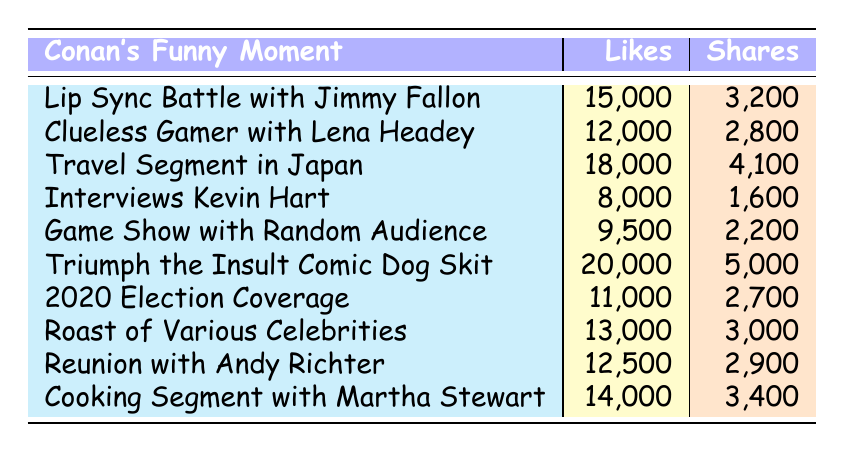What is the moment with the highest number of likes? By looking at the "Likes" column, the maximum value is 20,000, which corresponds to "Triumph the Insult Comic Dog Skit."
Answer: Triumph the Insult Comic Dog Skit What are the total likes for Conan's Cooking Segment with Martha Stewart and the Game Show with Random Audience Members combined? The likes for the Cooking Segment are 14,000 and for the Game Show are 9,500. Adding these gives 14,000 + 9,500 = 23,500.
Answer: 23,500 Did Conan's Interviews with Kevin Hart receive more shares than his Travel Segment in Japan? Conan's Interviews with Kevin Hart received 1,600 shares, while the Travel Segment in Japan received 4,100 shares. Since 1,600 is less than 4,100, the statement is false.
Answer: No What is the average number of likes for all the moments listed? To find the average, sum all the likes: 15,000 + 12,000 + 18,000 + 8,000 + 9,500 + 20,000 + 11,000 + 13,000 + 12,500 + 14,000 =  137,000. There are 10 moments, so the average likes = 137,000 / 10 = 13,700.
Answer: 13,700 Is the number of shares for "Conan's Lip Sync Battle with Jimmy Fallon" more than 3,000? The shares for the Lip Sync Battle are 3,200, which is greater than 3,000. Therefore, the answer is true.
Answer: Yes Which moment received the least number of likes? The least likes are 8,000, corresponding to "Conan Interviews Kevin Hart."
Answer: Conan Interviews Kevin Hart What is the difference in shares between the moment with the highest shares and the moment with the lowest shares? The highest shares are 5,000 (Triumph the Insult Comic Dog Skit) and the lowest are 1,600 (Interviews Kevin Hart). The difference is 5,000 - 1,600 = 3,400.
Answer: 3,400 Were the likes for "Clueless Gamer with Lena Headey" sufficient to exceed 10,000? The likes for Clueless Gamer are 12,000, which is greater than 10,000, making this statement true.
Answer: Yes 